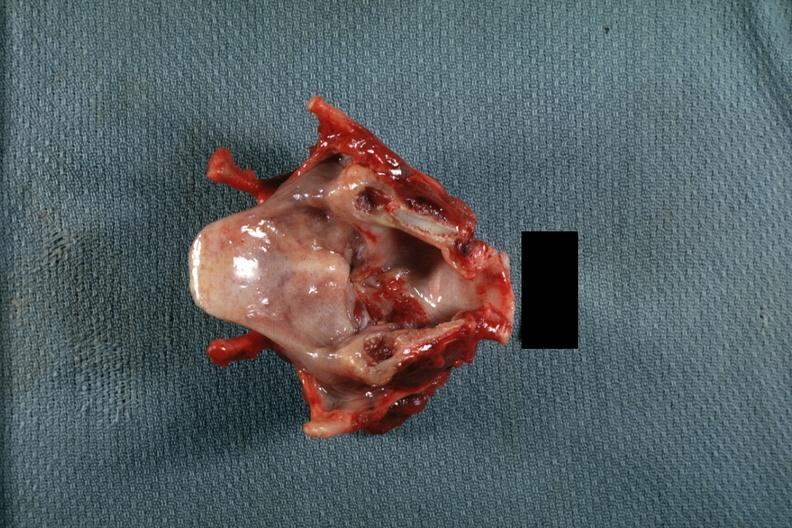where is this?
Answer the question using a single word or phrase. Oral 